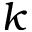Convert formula to latex. <formula><loc_0><loc_0><loc_500><loc_500>k</formula> 